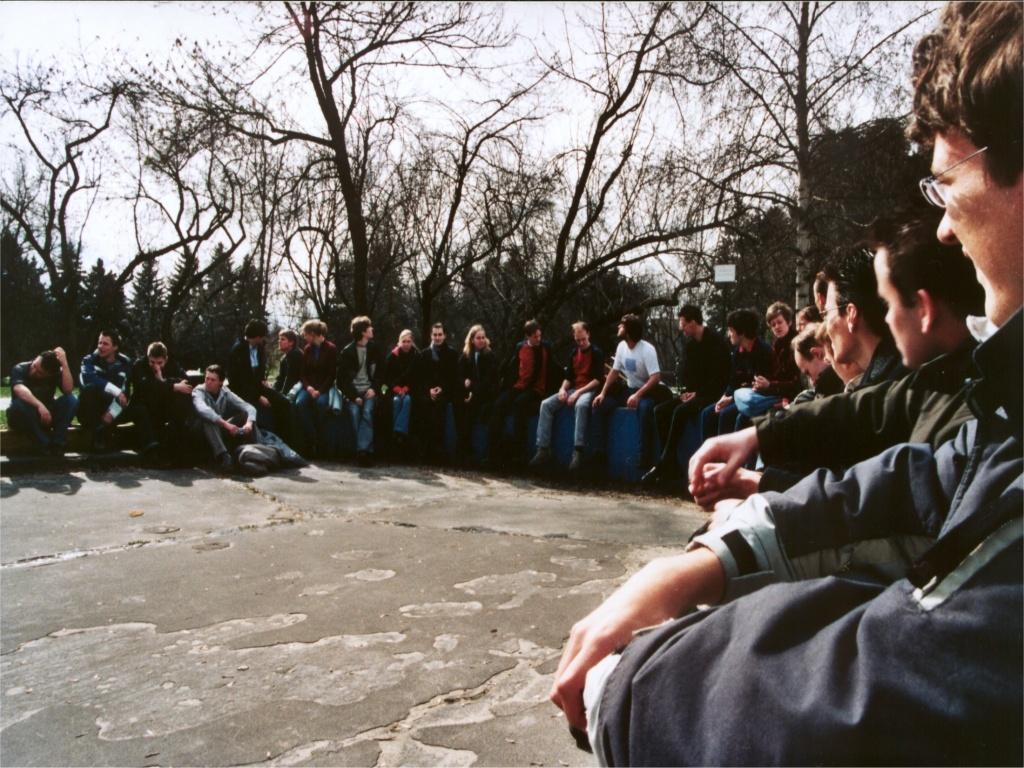How are the people arranged in the image? The people are sitting in a circular way in the image. What can be seen in the background of the image? There are trees and the sky visible in the background of the image. Is there any smoke coming from the playground in the image? There is no playground present in the image, so it is not possible to determine if there is any smoke coming from it. 